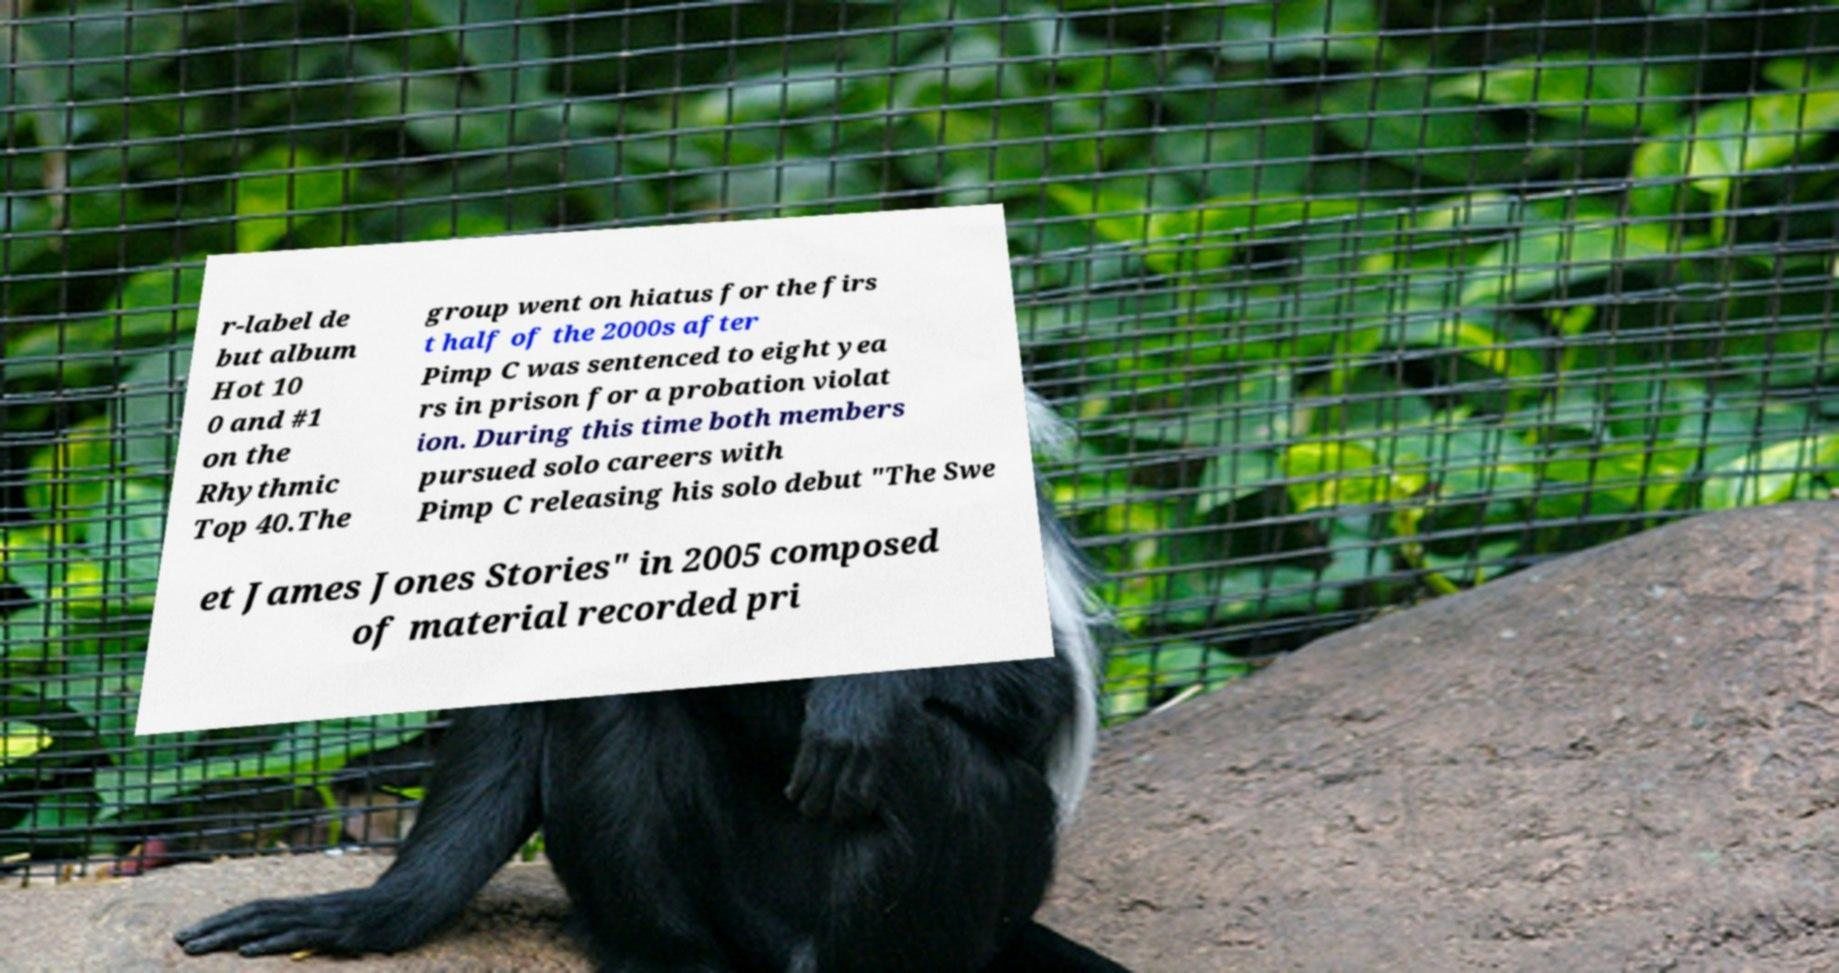For documentation purposes, I need the text within this image transcribed. Could you provide that? r-label de but album Hot 10 0 and #1 on the Rhythmic Top 40.The group went on hiatus for the firs t half of the 2000s after Pimp C was sentenced to eight yea rs in prison for a probation violat ion. During this time both members pursued solo careers with Pimp C releasing his solo debut "The Swe et James Jones Stories" in 2005 composed of material recorded pri 